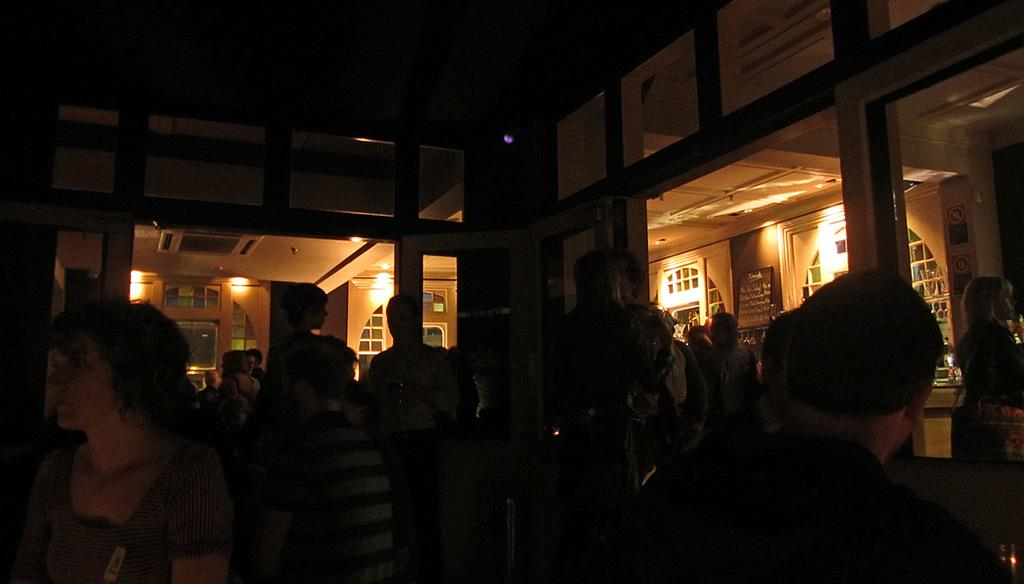What type of setting is depicted in the image? The image shows an inside view of a building. Can you describe what is happening at the bottom of the image? There is a crowd visible at the bottom of the image. What type of rule is being enforced by the popcorn in the image? There is no popcorn present in the image, and therefore no such rule enforcement can be observed. 